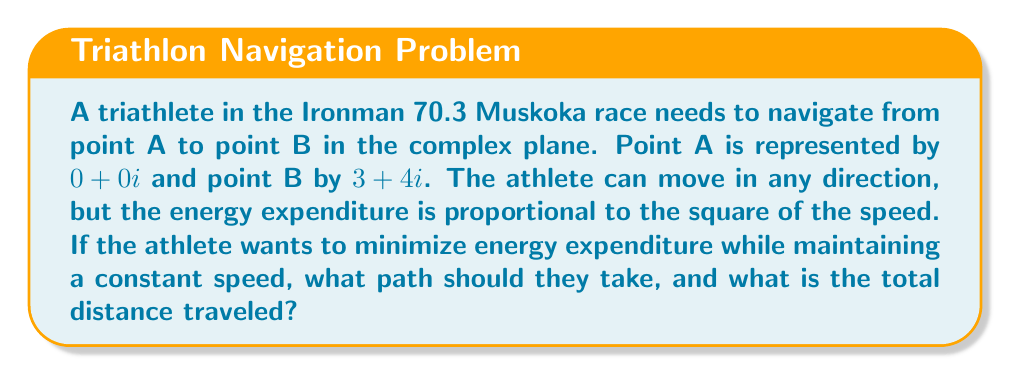Provide a solution to this math problem. To solve this problem, we'll use concepts from complex analysis and calculus of variations.

1) In the complex plane, the straight line between two points is always the shortest path. This is also the path that minimizes energy expenditure when maintaining constant speed.

2) The straight line path can be represented parametrically as:

   $$z(t) = (1-t)A + tB, \quad 0 \leq t \leq 1$$

   where $A = 0 + 0i$ and $B = 3 + 4i$

3) Substituting the values:

   $$z(t) = (1-t)(0 + 0i) + t(3 + 4i) = 3t + 4ti$$

4) The total distance traveled is the magnitude of the vector from A to B:

   $$|B - A| = |3 + 4i| = \sqrt{3^2 + 4^2} = \sqrt{9 + 16} = \sqrt{25} = 5$$

5) We can verify this using the distance formula in the complex plane:

   $$d = \sqrt{(\text{Re}(B) - \text{Re}(A))^2 + (\text{Im}(B) - \text{Im}(A))^2}$$
   $$d = \sqrt{(3 - 0)^2 + (4 - 0)^2} = \sqrt{9 + 16} = 5$$

6) The path can be visualized as follows:

[asy]
import graph;
size(200);
dot((0,0),red);
dot((3,4),red);
draw((0,0)--(3,4),blue);
label("A (0,0)",(0,0),SW);
label("B (3,4)",(3,4),NE);
xaxis(arrow=Arrow);
yaxis(arrow=Arrow);
[/asy]

Therefore, the optimal path for the triathlete is a straight line from point A to point B in the complex plane.
Answer: The optimal path is a straight line from $0 + 0i$ to $3 + 4i$, represented by $z(t) = 3t + 4ti$ for $0 \leq t \leq 1$. The total distance traveled is 5 units. 